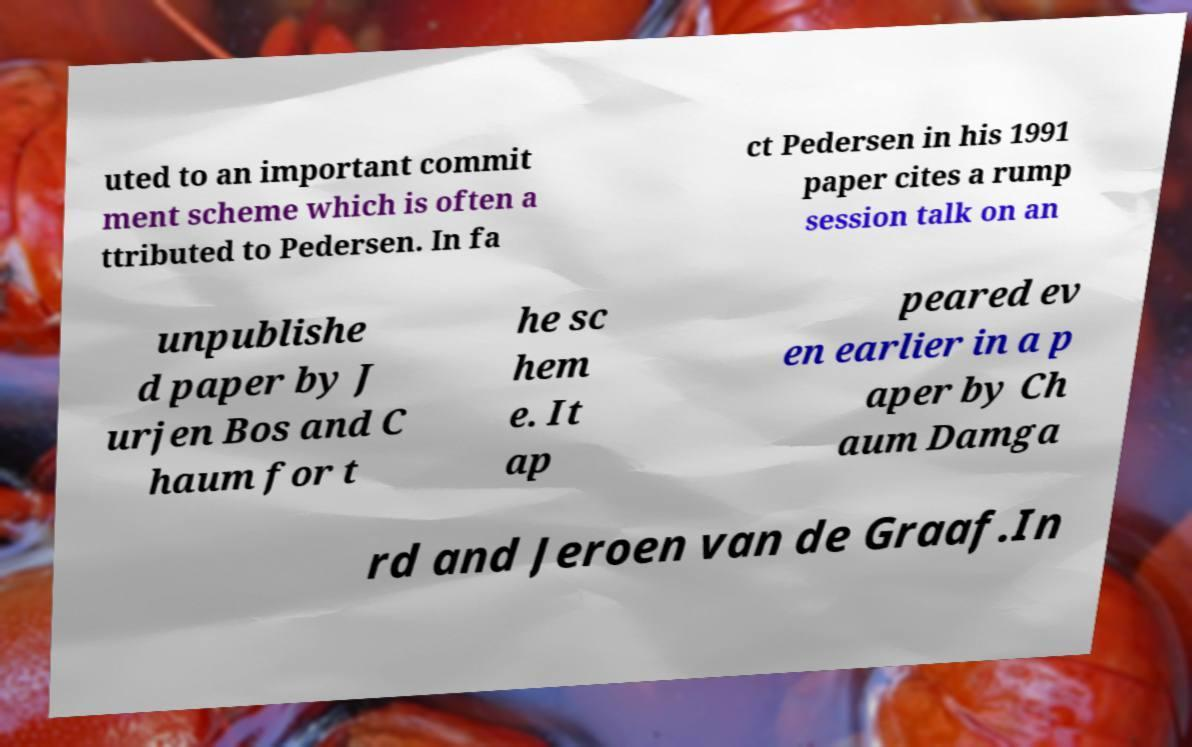Can you read and provide the text displayed in the image?This photo seems to have some interesting text. Can you extract and type it out for me? uted to an important commit ment scheme which is often a ttributed to Pedersen. In fa ct Pedersen in his 1991 paper cites a rump session talk on an unpublishe d paper by J urjen Bos and C haum for t he sc hem e. It ap peared ev en earlier in a p aper by Ch aum Damga rd and Jeroen van de Graaf.In 